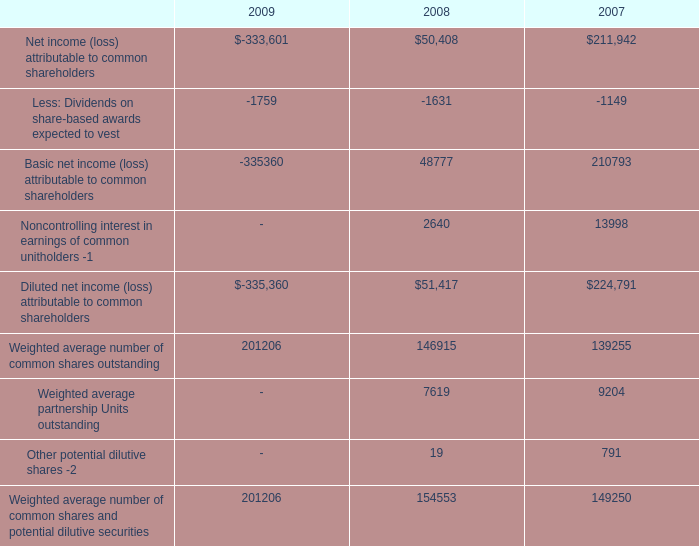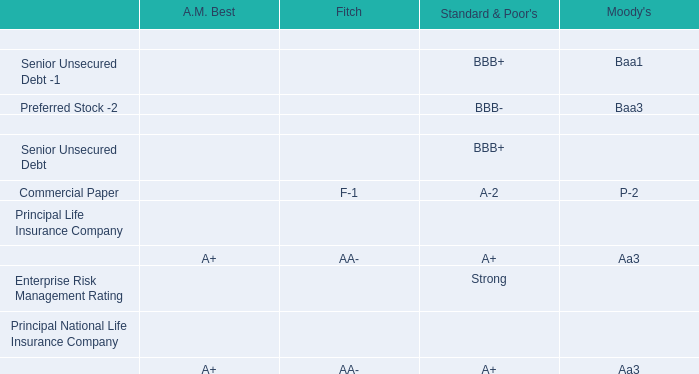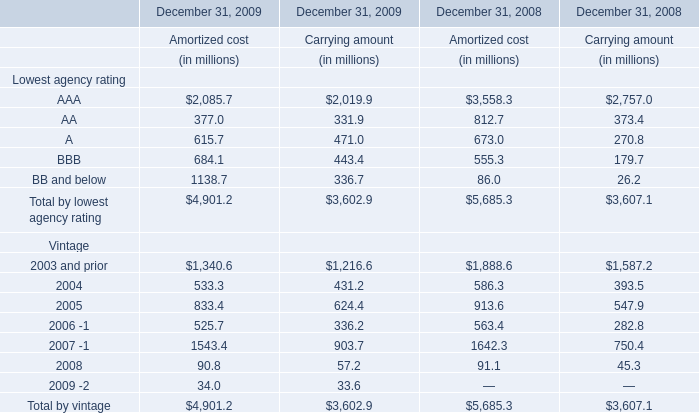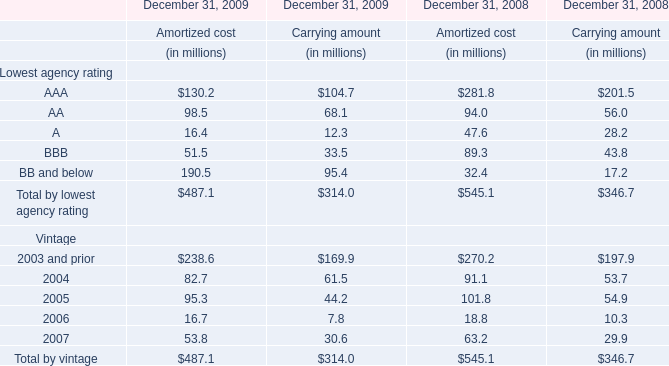If AA for Carrying amount develops with the same growth rate in 2009, what will it reach in 2010? (in million) 
Computations: (68.1 * (1 + ((68.1 - 56) / 56)))
Answer: 82.81446. 